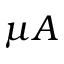Convert formula to latex. <formula><loc_0><loc_0><loc_500><loc_500>\mu A</formula> 